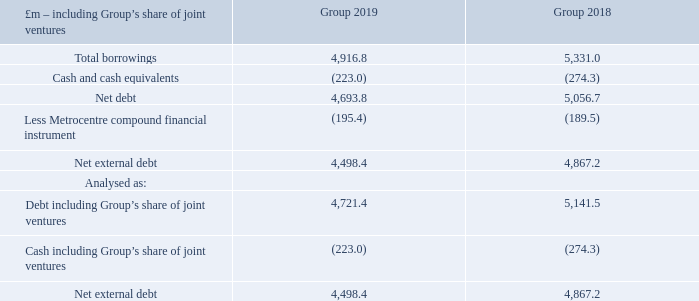Capital structure
The Group seeks to enhance shareholder value both by investing in the business so as to improve the return on investment and by managing the capital structure. The capital of the Group consists of equity, debt and a compound financial instrument. The Group aims to access both debt and equity capital markets with maximum efficiency and flexibility.
The key metrics used to monitor the capital structure of the Group are net external debt, debt to assets ratio and interest cover. The Group’s stated medium to long-term preference is for the debt to assets ratio to be within the 40–50 per cent range and interest cover to be greater than 1.60x. The debt to assets ratio has increased to 67.8 per cent in the year due to the deficit on property revaluation. As part of the revised strategy, the Group is looking to reduce net external debt as well as reduce the debt to assets ratio to below 50 per cent. Additional information on the Group’s revised strategy is provided in the chief executive’s review on pages 6 to 8. The interest cover ratio continues to be above the preferred level.
As the Group’s debt is sometimes secured on its interests in joint ventures, these metrics are monitored for the Group including share of joint ventures. Additional information including reconciliations from the relevant IFRS amounts to those including the Group’s share of joint ventures as presented below is provided in presentation of information on pages 157 to 161.
– net external debt
What is the total borrowings in 2019?
Answer scale should be: million. 4,916.8. What is the total borrowings in 2018?
Answer scale should be: million. 5,331.0. What is the Net debt in 2019?
Answer scale should be: million. 4,693.8. What is the percentage change in the net debt from 2018 to 2019?
Answer scale should be: percent. (4,693.8-5,056.7)/5,056.7
Answer: -7.18. What is the percentage change in the net external debt from 2018 to 2019?
Answer scale should be: percent. (4,498.4-4,867.2)/ 4,867.2
Answer: -7.58. What is the percentage of total borrowings in net debt in 2019?
Answer scale should be: percent. 4,916.8/4,693.8
Answer: 104.75. 